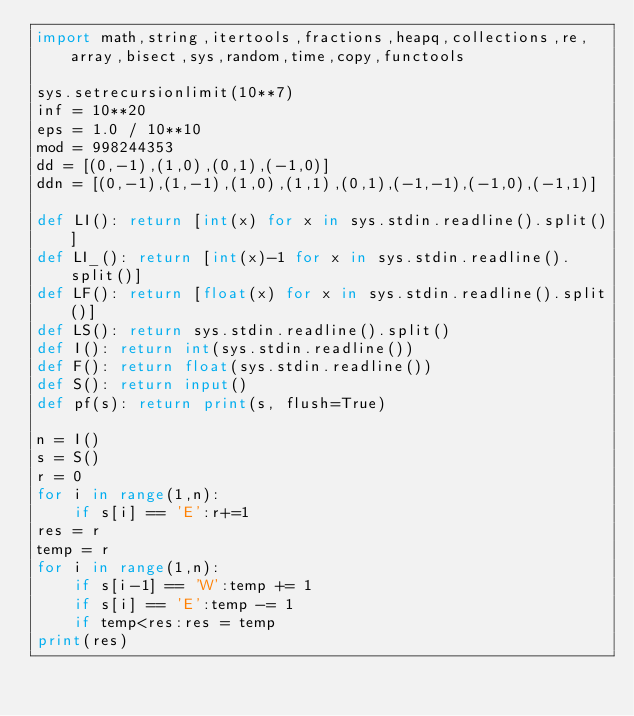Convert code to text. <code><loc_0><loc_0><loc_500><loc_500><_Python_>import math,string,itertools,fractions,heapq,collections,re,array,bisect,sys,random,time,copy,functools

sys.setrecursionlimit(10**7)
inf = 10**20
eps = 1.0 / 10**10
mod = 998244353
dd = [(0,-1),(1,0),(0,1),(-1,0)]
ddn = [(0,-1),(1,-1),(1,0),(1,1),(0,1),(-1,-1),(-1,0),(-1,1)]

def LI(): return [int(x) for x in sys.stdin.readline().split()]
def LI_(): return [int(x)-1 for x in sys.stdin.readline().split()]
def LF(): return [float(x) for x in sys.stdin.readline().split()]
def LS(): return sys.stdin.readline().split()
def I(): return int(sys.stdin.readline())
def F(): return float(sys.stdin.readline())
def S(): return input()
def pf(s): return print(s, flush=True)

n = I()
s = S()
r = 0
for i in range(1,n):
    if s[i] == 'E':r+=1
res = r
temp = r
for i in range(1,n):
    if s[i-1] == 'W':temp += 1
    if s[i] == 'E':temp -= 1
    if temp<res:res = temp
print(res)



</code> 